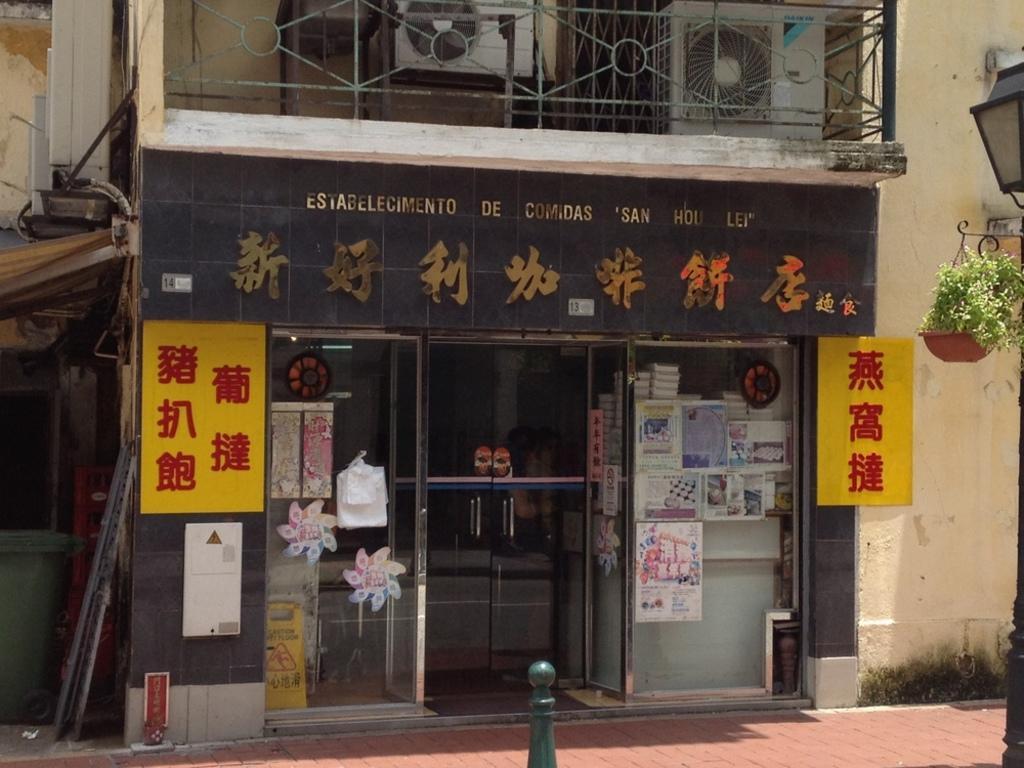In one or two sentences, can you explain what this image depicts? In this image in the center there is a building. In the center there is a glass door and there are some text written on the top of the door. On the right side there is a pole and there is a flower pot hanging. 